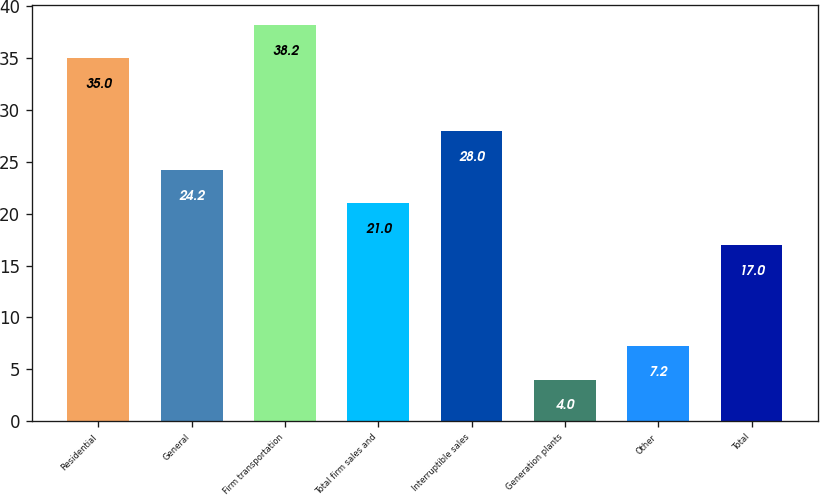<chart> <loc_0><loc_0><loc_500><loc_500><bar_chart><fcel>Residential<fcel>General<fcel>Firm transportation<fcel>Total firm sales and<fcel>Interruptible sales<fcel>Generation plants<fcel>Other<fcel>Total<nl><fcel>35<fcel>24.2<fcel>38.2<fcel>21<fcel>28<fcel>4<fcel>7.2<fcel>17<nl></chart> 